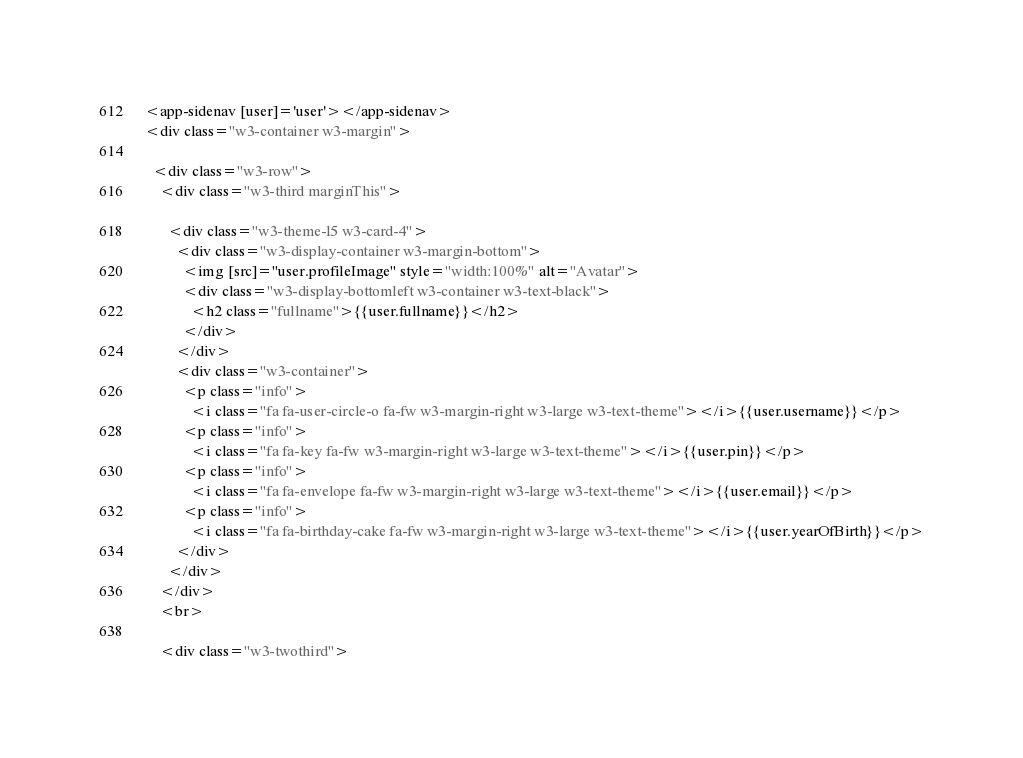Convert code to text. <code><loc_0><loc_0><loc_500><loc_500><_HTML_><app-sidenav [user]='user'></app-sidenav>
<div class="w3-container w3-margin">

  <div class="w3-row">
    <div class="w3-third marginThis">

      <div class="w3-theme-l5 w3-card-4">
        <div class="w3-display-container w3-margin-bottom">
          <img [src]="user.profileImage" style="width:100%" alt="Avatar">
          <div class="w3-display-bottomleft w3-container w3-text-black">
            <h2 class="fullname">{{user.fullname}}</h2>
          </div>
        </div>
        <div class="w3-container">
          <p class="info">
            <i class="fa fa-user-circle-o fa-fw w3-margin-right w3-large w3-text-theme"></i>{{user.username}}</p>
          <p class="info">
            <i class="fa fa-key fa-fw w3-margin-right w3-large w3-text-theme"></i>{{user.pin}}</p>
          <p class="info">
            <i class="fa fa-envelope fa-fw w3-margin-right w3-large w3-text-theme"></i>{{user.email}}</p>
          <p class="info">
            <i class="fa fa-birthday-cake fa-fw w3-margin-right w3-large w3-text-theme"></i>{{user.yearOfBirth}}</p>
        </div>
      </div>
    </div>
    <br>

    <div class="w3-twothird"></code> 